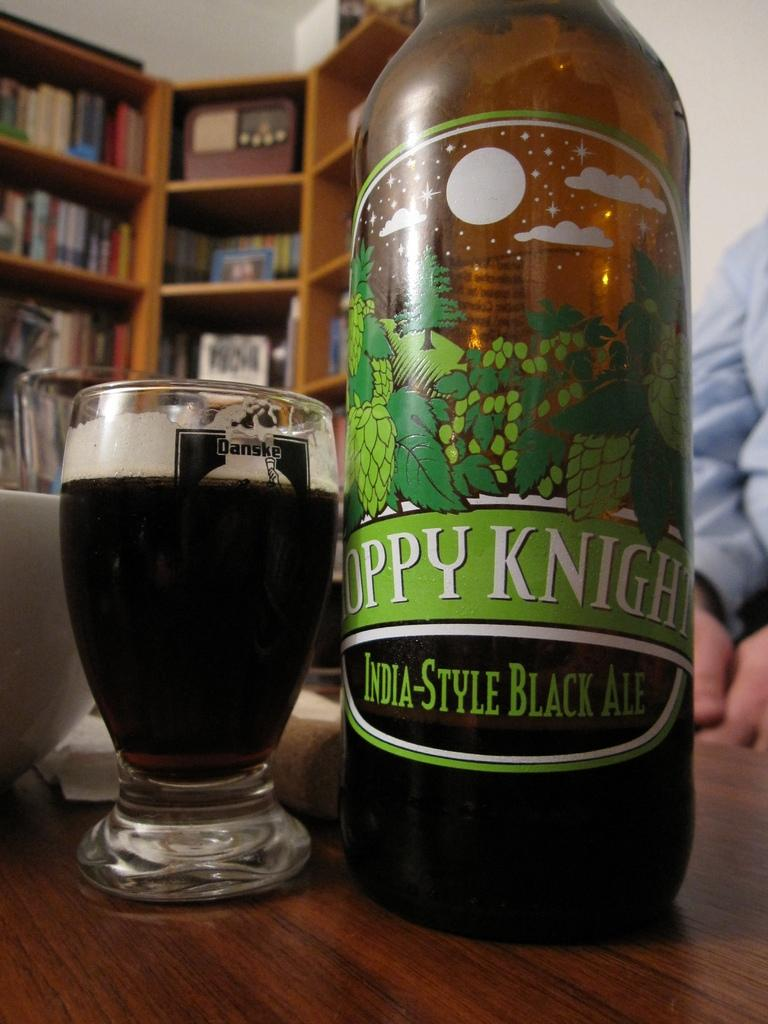<image>
Present a compact description of the photo's key features. Bottle that srays "India-Style Black Ale" next to a cup of beer. 